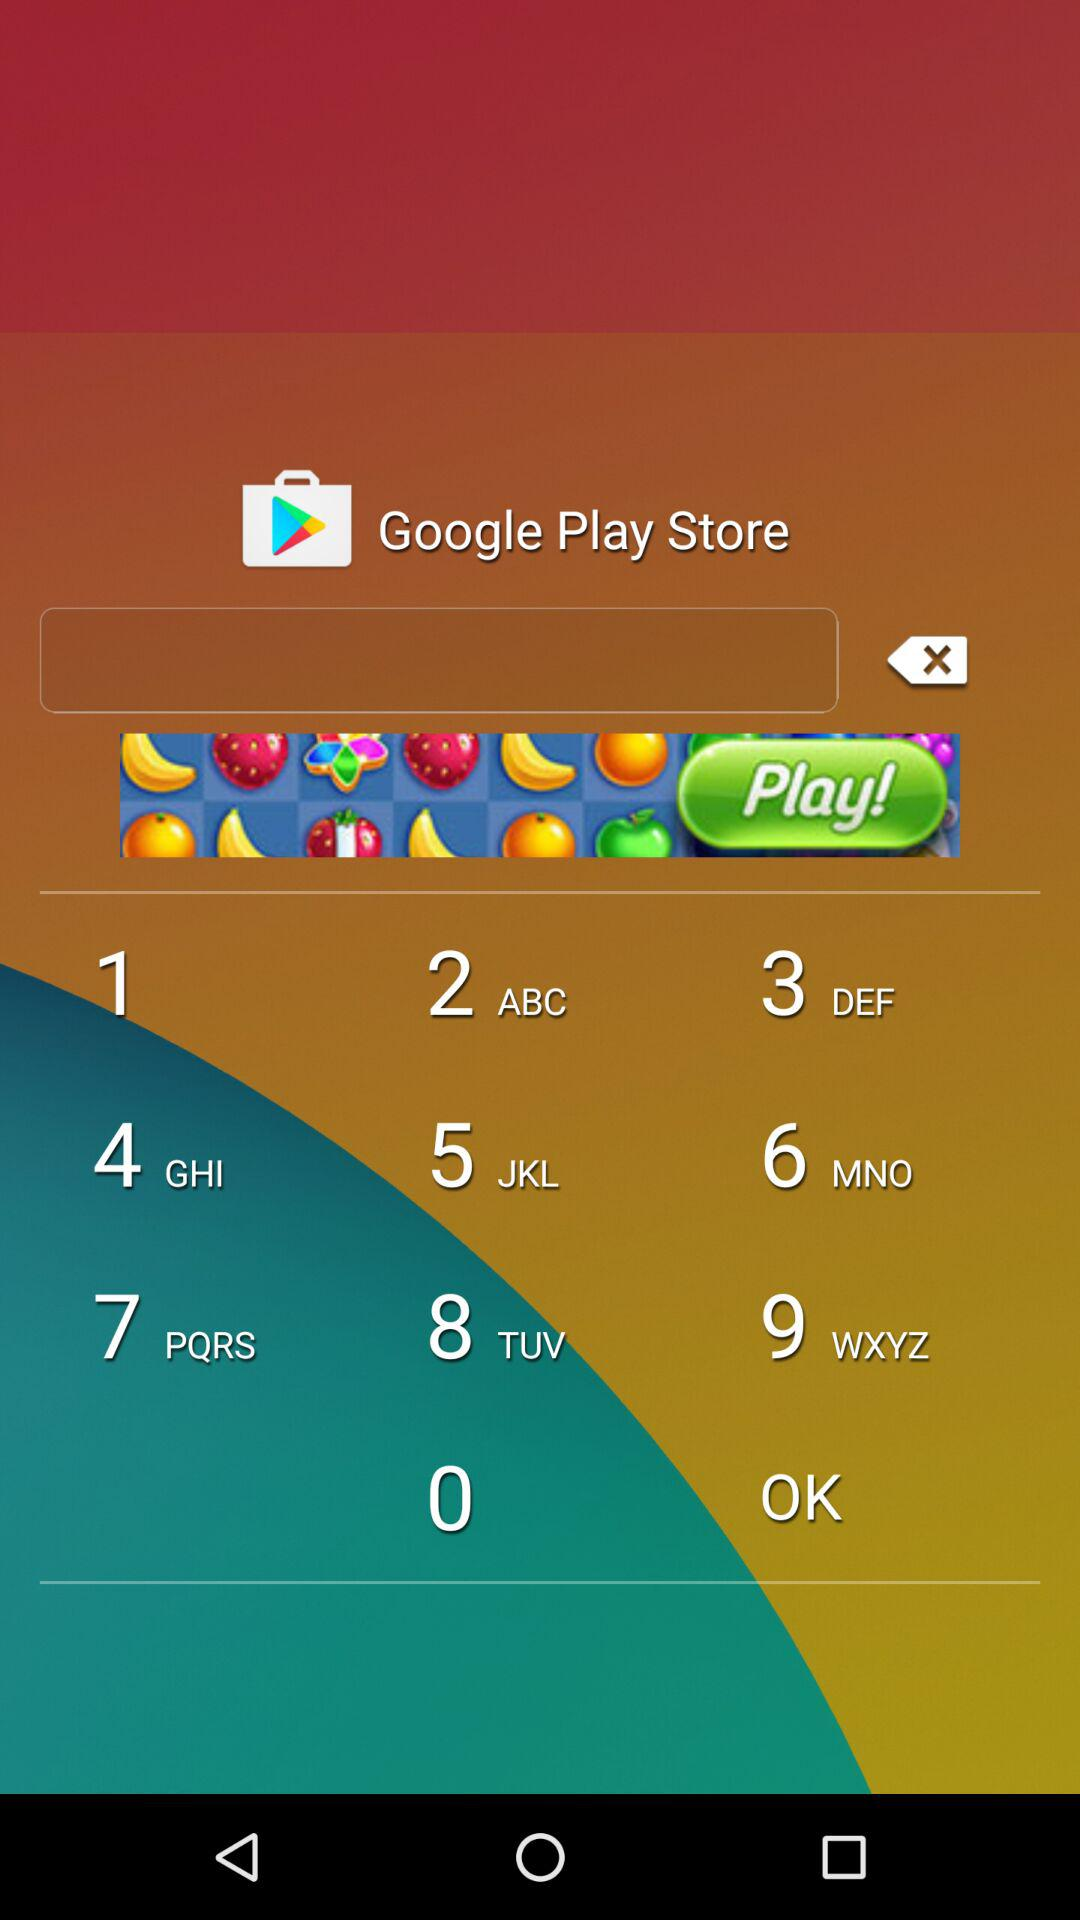What is the date range mentioned for glucose screening? The mentioned date range for glucose screening is from September 1, 2017 to September 29, 2017. 